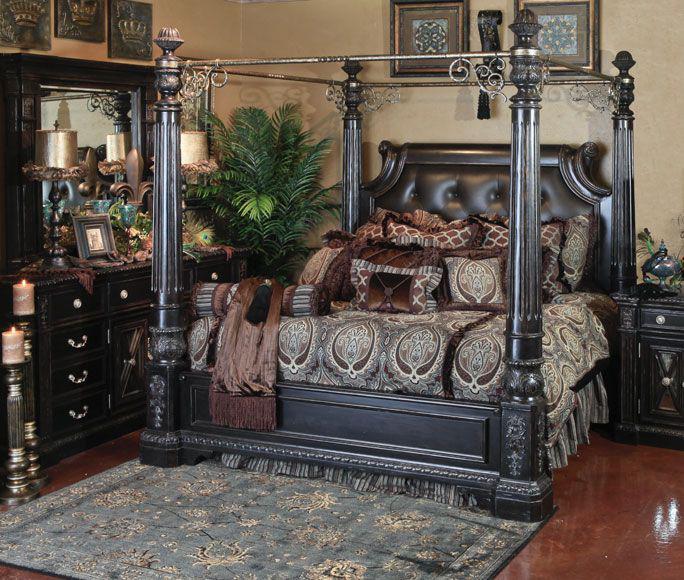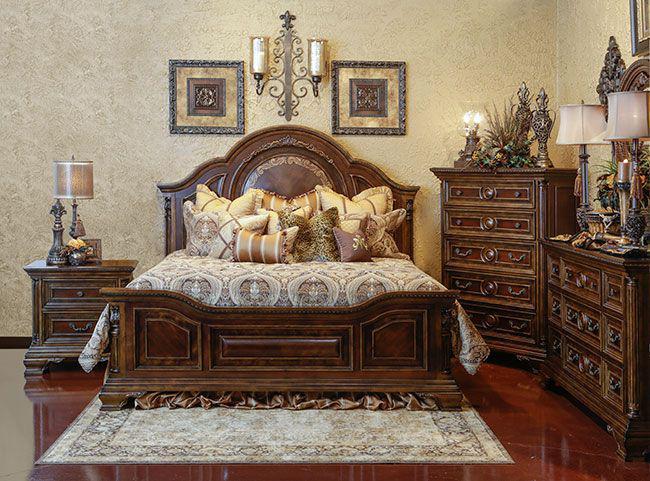The first image is the image on the left, the second image is the image on the right. For the images displayed, is the sentence "In at least one image, no framed wall art is displayed in the bedroom." factually correct? Answer yes or no. No. 